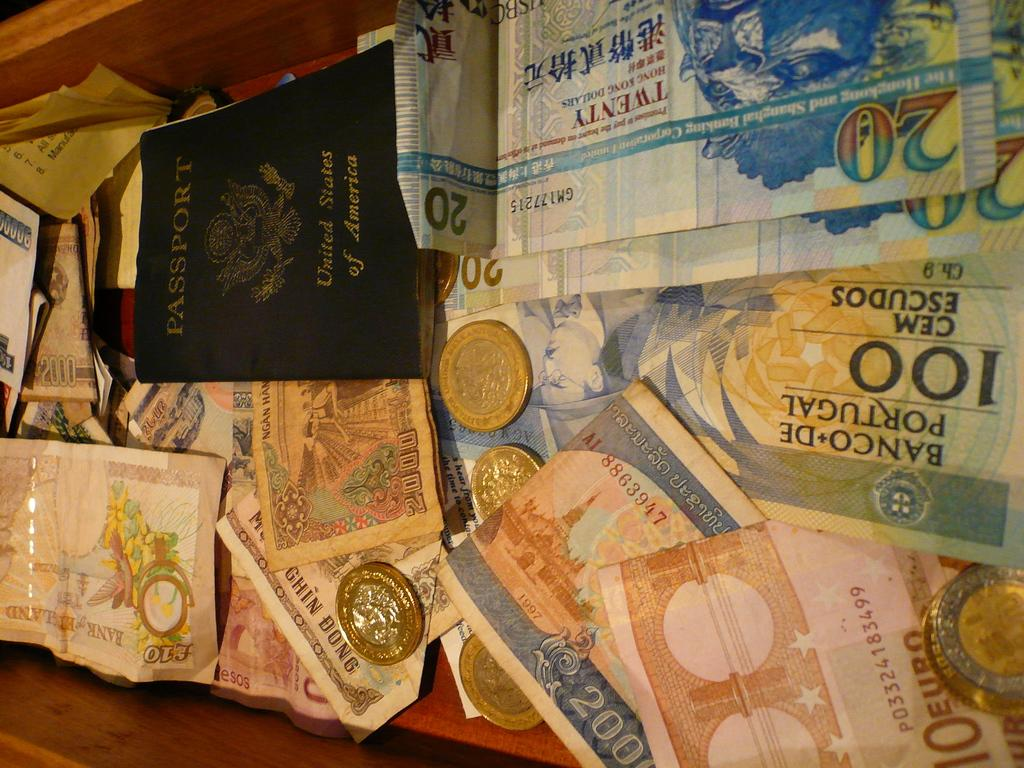<image>
Summarize the visual content of the image. Portuguese bank notes of 10, 20 and 100 denomination 